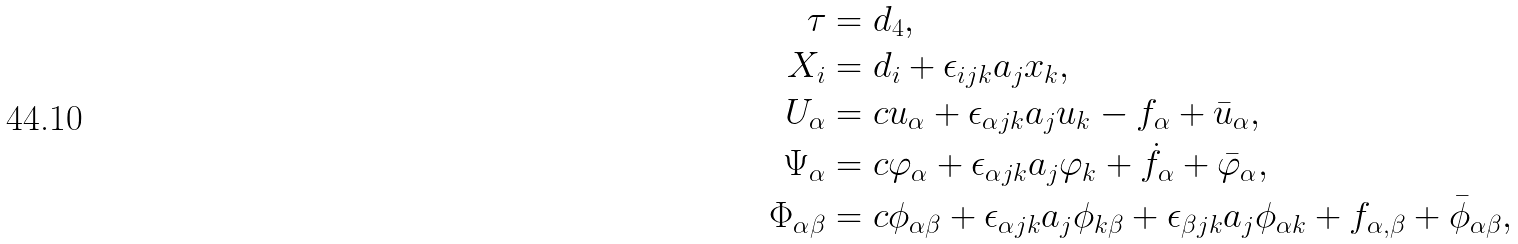<formula> <loc_0><loc_0><loc_500><loc_500>\tau & = d _ { 4 } , \\ X _ { i } & = d _ { i } + \epsilon _ { i j k } a _ { j } x _ { k } , \\ U _ { \alpha } & = c u _ { \alpha } + \epsilon _ { \alpha j k } a _ { j } u _ { k } - f _ { \alpha } + \bar { u } _ { \alpha } , \\ \Psi _ { \alpha } & = c \varphi _ { \alpha } + \epsilon _ { \alpha j k } a _ { j } \varphi _ { k } + \dot { f } _ { \alpha } + \bar { \varphi } _ { \alpha } , \\ \Phi _ { \alpha \beta } & = c \phi _ { \alpha \beta } + \epsilon _ { \alpha j k } a _ { j } \phi _ { k \beta } + \epsilon _ { \beta j k } a _ { j } \phi _ { \alpha k } + f _ { \alpha , \beta } + \bar { \phi } _ { \alpha \beta } ,</formula> 